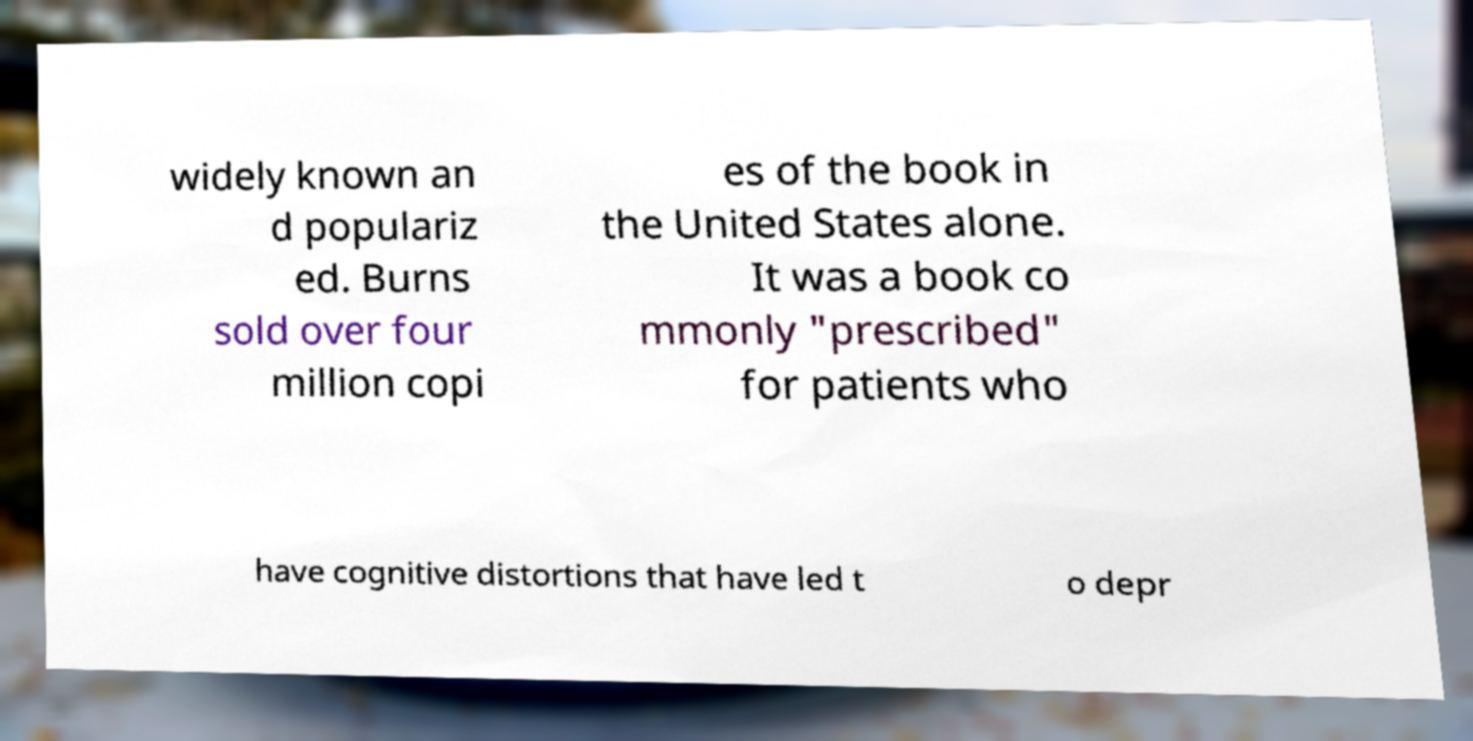Please read and relay the text visible in this image. What does it say? widely known an d populariz ed. Burns sold over four million copi es of the book in the United States alone. It was a book co mmonly "prescribed" for patients who have cognitive distortions that have led t o depr 